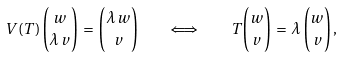Convert formula to latex. <formula><loc_0><loc_0><loc_500><loc_500>V ( T ) \, \binom { w } { \lambda \, v } \, = \, \binom { \lambda \, w } { v } \quad \Longleftrightarrow \quad T \binom { w } { v } \, = \, \lambda \, \binom { w } { v } \, ,</formula> 